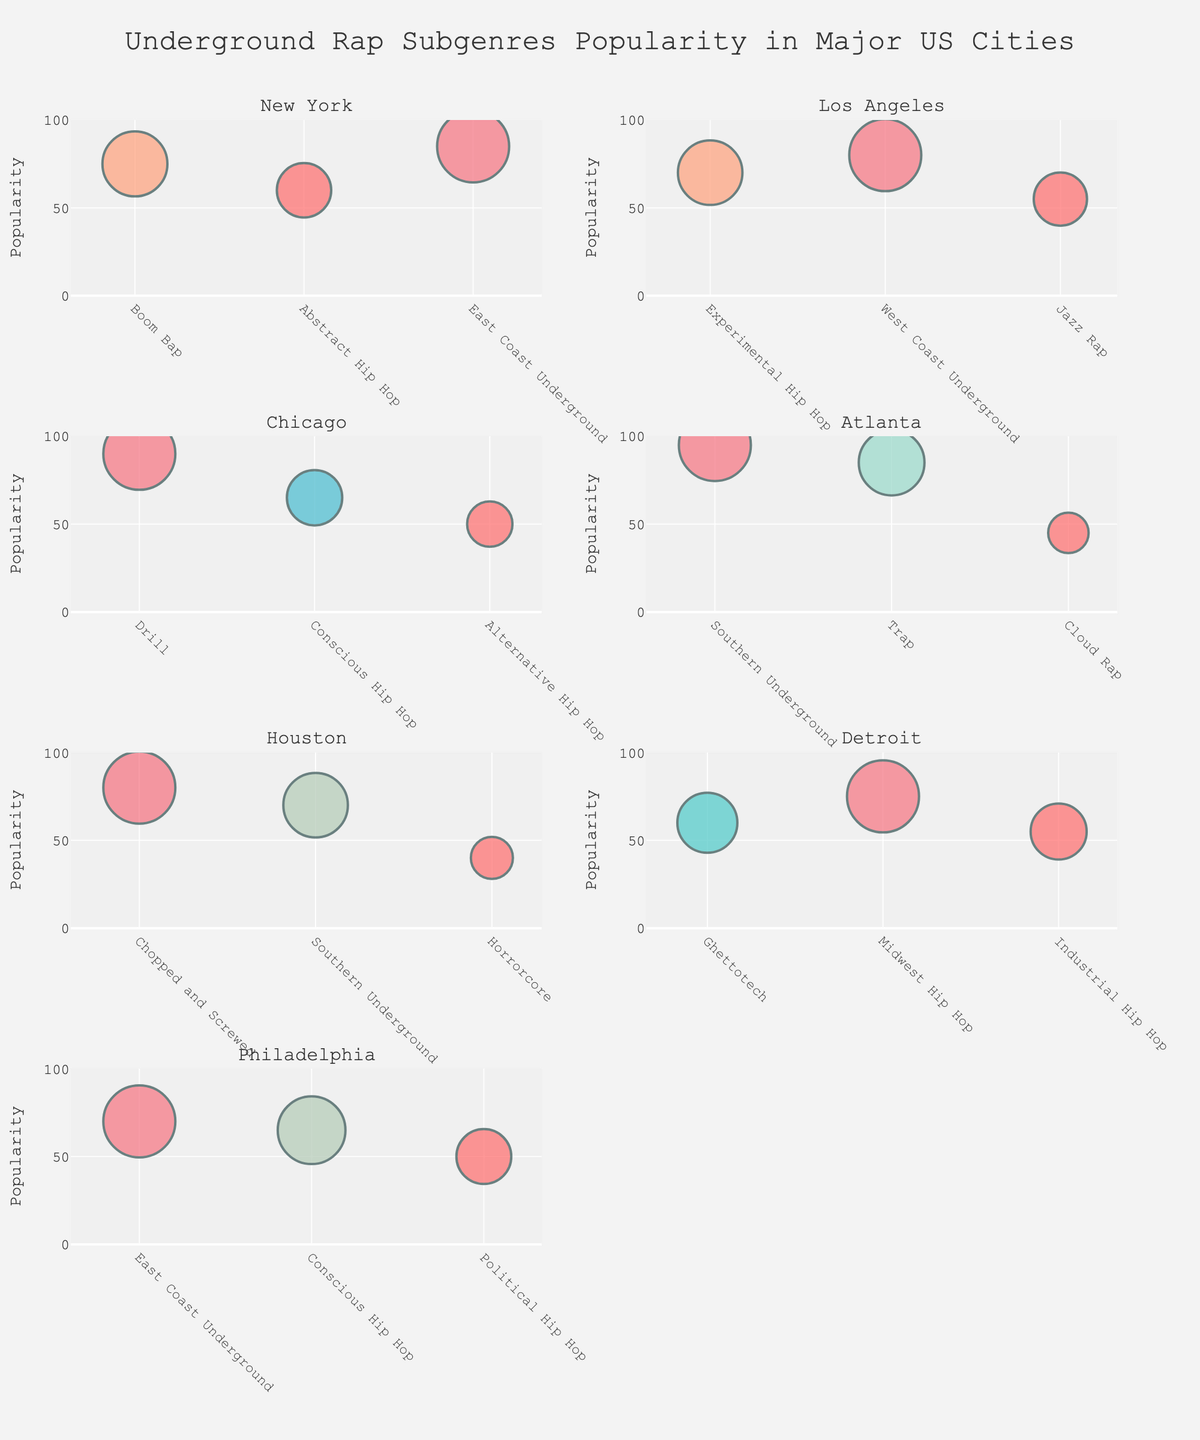What's the most popular underground rap subgenre in Chicago? Chicago has several subgenres shown in the subplot for the city. The one with the highest popularity is Drill with a value of 90.
Answer: Drill Which city has the least popular subgenre, and what is it? Each city has different subgenres with varying popularities. The smallest bubble (least popular subgenre) is for Horrorcore in Houston with a popularity of 40.
Answer: Houston, Horrorcore What is the average popularity of subgenres in Detroit? To find the average popularity of subgenres in Detroit, sum up the popularity values and divide by the number of subgenres: (60 + 75 + 55) / 3 = 63.33.
Answer: 63.33 Compare Boom Bap in New York and Trap in Atlanta. Which subgenre is more popular? The popularity of Boom Bap in New York is 75, while Trap in Atlanta has a popularity of 85. Therefore, Trap in Atlanta is more popular.
Answer: Trap in Atlanta How many subgenres in Los Angeles have a popularity greater than 60? By looking at the bubbles in the Los Angeles subplot, West Coast Underground has a popularity of 80, and Experimental Hip Hop has a popularity of 70. Both are greater than 60.
Answer: 2 Identify the city with the highest median subgenre popularity. First, find the median popularity for each city. For New York: 60, 75, 85 (median 75); Los Angeles: 55, 70, 80 (median 70); Chicago: 50, 65, 90 (median 65); Atlanta: 45, 85, 95 (median 85); Houston: 40, 70, 80 (median 70); Detroit: 55, 60, 75 (median 60); Philadelphia: 50, 65, 70 (median 65). Atlanta has the highest median of 85.
Answer: Atlanta Is Conscious Hip Hop more popular in Chicago or Philadelphia? In Chicago, Conscious Hip Hop has a popularity of 65, while in Philadelphia, it also has a popularity of 65. So, the popularity is the same in both cities.
Answer: Same Which subgenre has the largest range in popularity across different cities? Calculate the range for each subgenre by finding the difference between the highest and lowest popularity values. East Coast Underground: New York (85), Philadelphia (70) -> range 15. Southern Underground: Atlanta (95), Houston (70) -> range 25. Hence, Southern Underground has the largest range (25).
Answer: Southern Underground What is the total number of subgenres with a popularity above 80 across all cities? Calculate the total number by counting the subgenres with popularity above 80 in all cities: East Coast Underground (New York: 85), Drill (Chicago: 90), Southern Underground (Atlanta: 95), Trap (Atlanta: 85). There are four subgenres above 80.
Answer: 4 